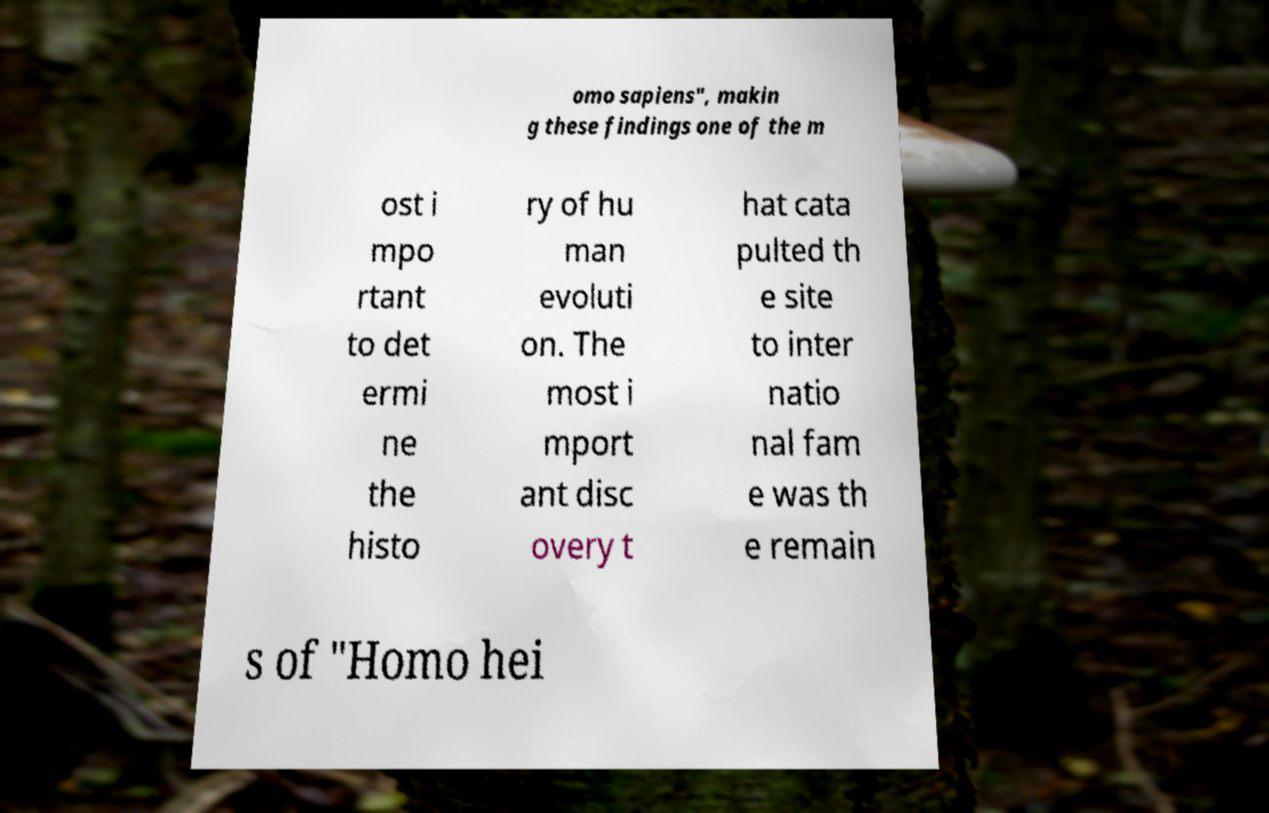Please read and relay the text visible in this image. What does it say? omo sapiens", makin g these findings one of the m ost i mpo rtant to det ermi ne the histo ry of hu man evoluti on. The most i mport ant disc overy t hat cata pulted th e site to inter natio nal fam e was th e remain s of "Homo hei 